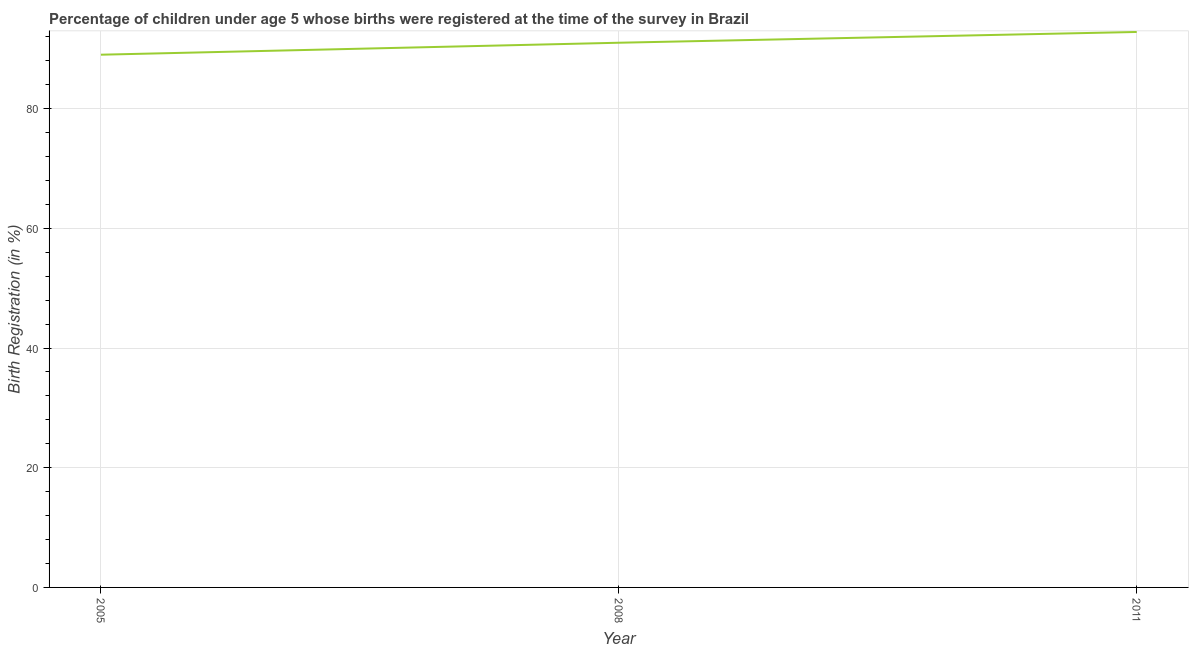What is the birth registration in 2011?
Make the answer very short. 92.8. Across all years, what is the maximum birth registration?
Your answer should be very brief. 92.8. Across all years, what is the minimum birth registration?
Your answer should be very brief. 89. In which year was the birth registration maximum?
Your response must be concise. 2011. What is the sum of the birth registration?
Give a very brief answer. 272.8. What is the difference between the birth registration in 2008 and 2011?
Ensure brevity in your answer.  -1.8. What is the average birth registration per year?
Make the answer very short. 90.93. What is the median birth registration?
Make the answer very short. 91. In how many years, is the birth registration greater than 44 %?
Provide a succinct answer. 3. What is the ratio of the birth registration in 2005 to that in 2011?
Offer a terse response. 0.96. Is the difference between the birth registration in 2005 and 2011 greater than the difference between any two years?
Your answer should be very brief. Yes. What is the difference between the highest and the second highest birth registration?
Make the answer very short. 1.8. What is the difference between the highest and the lowest birth registration?
Make the answer very short. 3.8. How many lines are there?
Make the answer very short. 1. What is the difference between two consecutive major ticks on the Y-axis?
Provide a short and direct response. 20. What is the title of the graph?
Provide a succinct answer. Percentage of children under age 5 whose births were registered at the time of the survey in Brazil. What is the label or title of the X-axis?
Your answer should be compact. Year. What is the label or title of the Y-axis?
Keep it short and to the point. Birth Registration (in %). What is the Birth Registration (in %) in 2005?
Provide a short and direct response. 89. What is the Birth Registration (in %) of 2008?
Offer a terse response. 91. What is the Birth Registration (in %) in 2011?
Your answer should be very brief. 92.8. What is the difference between the Birth Registration (in %) in 2008 and 2011?
Keep it short and to the point. -1.8. What is the ratio of the Birth Registration (in %) in 2005 to that in 2011?
Your answer should be compact. 0.96. What is the ratio of the Birth Registration (in %) in 2008 to that in 2011?
Your response must be concise. 0.98. 